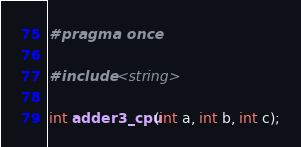Convert code to text. <code><loc_0><loc_0><loc_500><loc_500><_C_>#pragma once

#include <string>

int adder3_cpu(int a, int b, int c);
</code> 